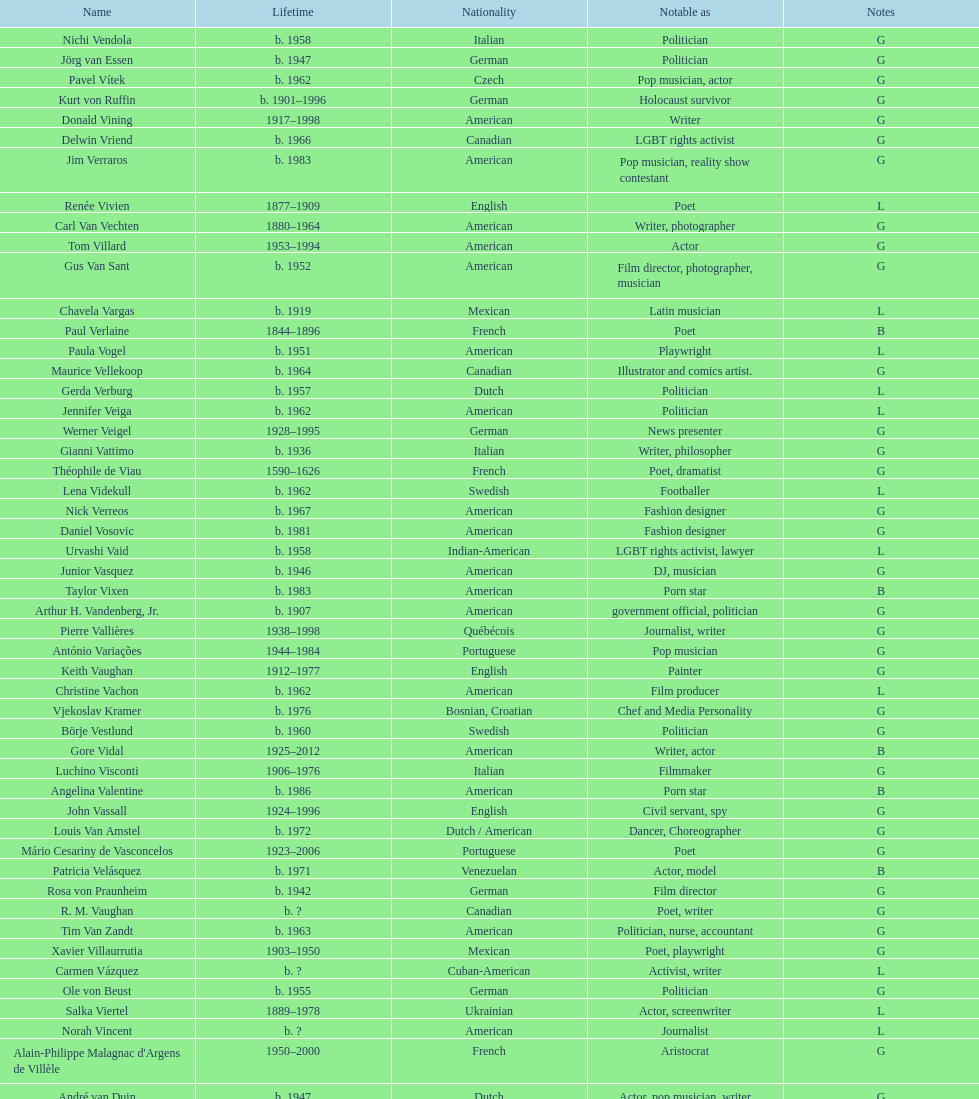Which is the previous name from lupe valdez Urvashi Vaid. 